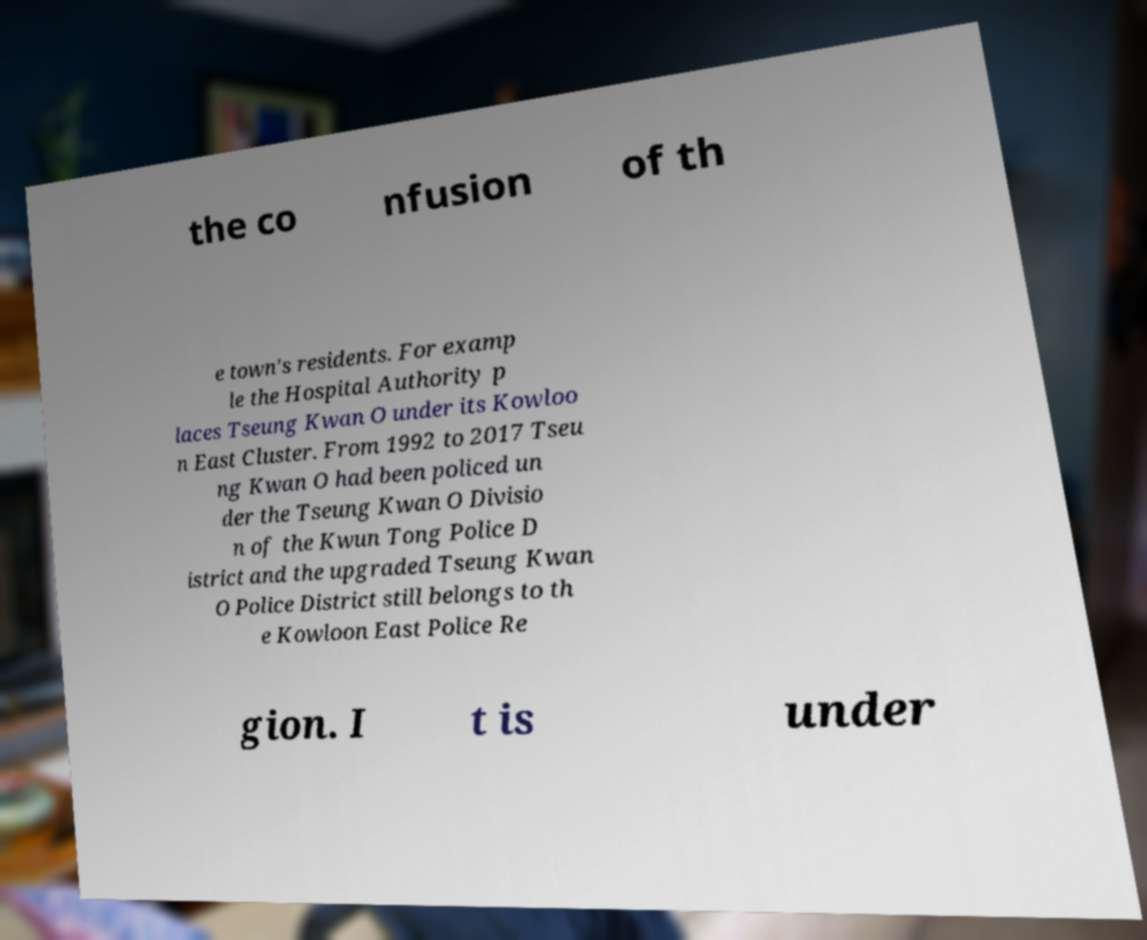There's text embedded in this image that I need extracted. Can you transcribe it verbatim? the co nfusion of th e town's residents. For examp le the Hospital Authority p laces Tseung Kwan O under its Kowloo n East Cluster. From 1992 to 2017 Tseu ng Kwan O had been policed un der the Tseung Kwan O Divisio n of the Kwun Tong Police D istrict and the upgraded Tseung Kwan O Police District still belongs to th e Kowloon East Police Re gion. I t is under 